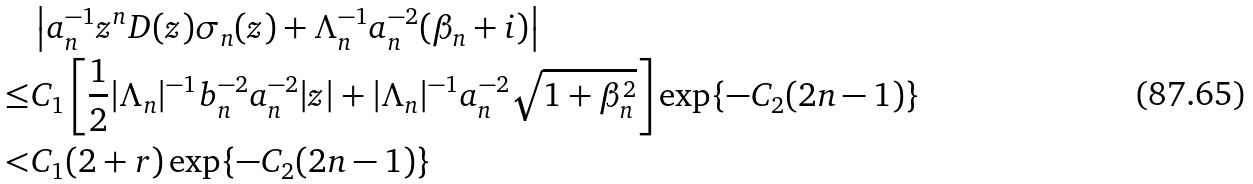Convert formula to latex. <formula><loc_0><loc_0><loc_500><loc_500>& \left | a _ { n } ^ { - 1 } z ^ { n } D ( z ) \sigma _ { n } ( z ) + \Lambda _ { n } ^ { - 1 } a _ { n } ^ { - 2 } ( \beta _ { n } + i ) \right | \\ \leq & C _ { 1 } \left [ \frac { 1 } { 2 } | \Lambda _ { n } | ^ { - 1 } b _ { n } ^ { - 2 } a _ { n } ^ { - 2 } | z | + | \Lambda _ { n } | ^ { - 1 } a _ { n } ^ { - 2 } \sqrt { 1 + \beta _ { n } ^ { 2 } } \right ] \exp \{ - C _ { 2 } ( 2 n - 1 ) \} \\ < & C _ { 1 } ( 2 + r ) \exp \{ - C _ { 2 } ( 2 n - 1 ) \}</formula> 